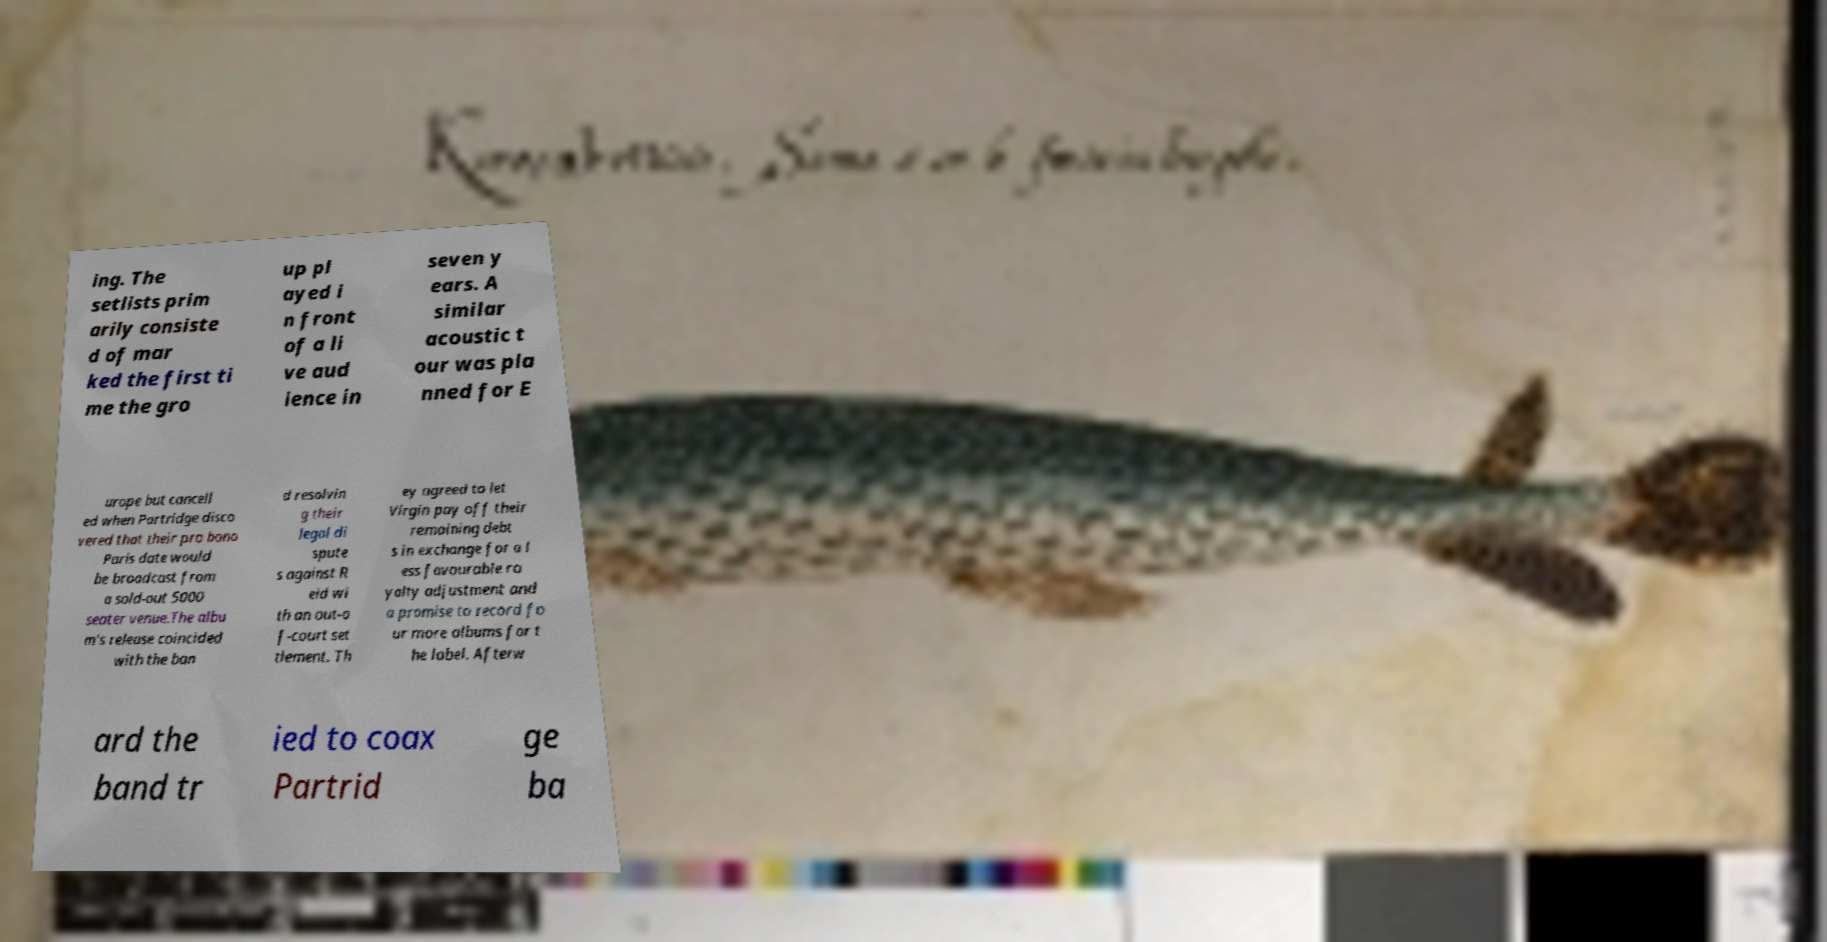Please identify and transcribe the text found in this image. ing. The setlists prim arily consiste d of mar ked the first ti me the gro up pl ayed i n front of a li ve aud ience in seven y ears. A similar acoustic t our was pla nned for E urope but cancell ed when Partridge disco vered that their pro bono Paris date would be broadcast from a sold-out 5000 seater venue.The albu m's release coincided with the ban d resolvin g their legal di spute s against R eid wi th an out-o f-court set tlement. Th ey agreed to let Virgin pay off their remaining debt s in exchange for a l ess favourable ro yalty adjustment and a promise to record fo ur more albums for t he label. Afterw ard the band tr ied to coax Partrid ge ba 